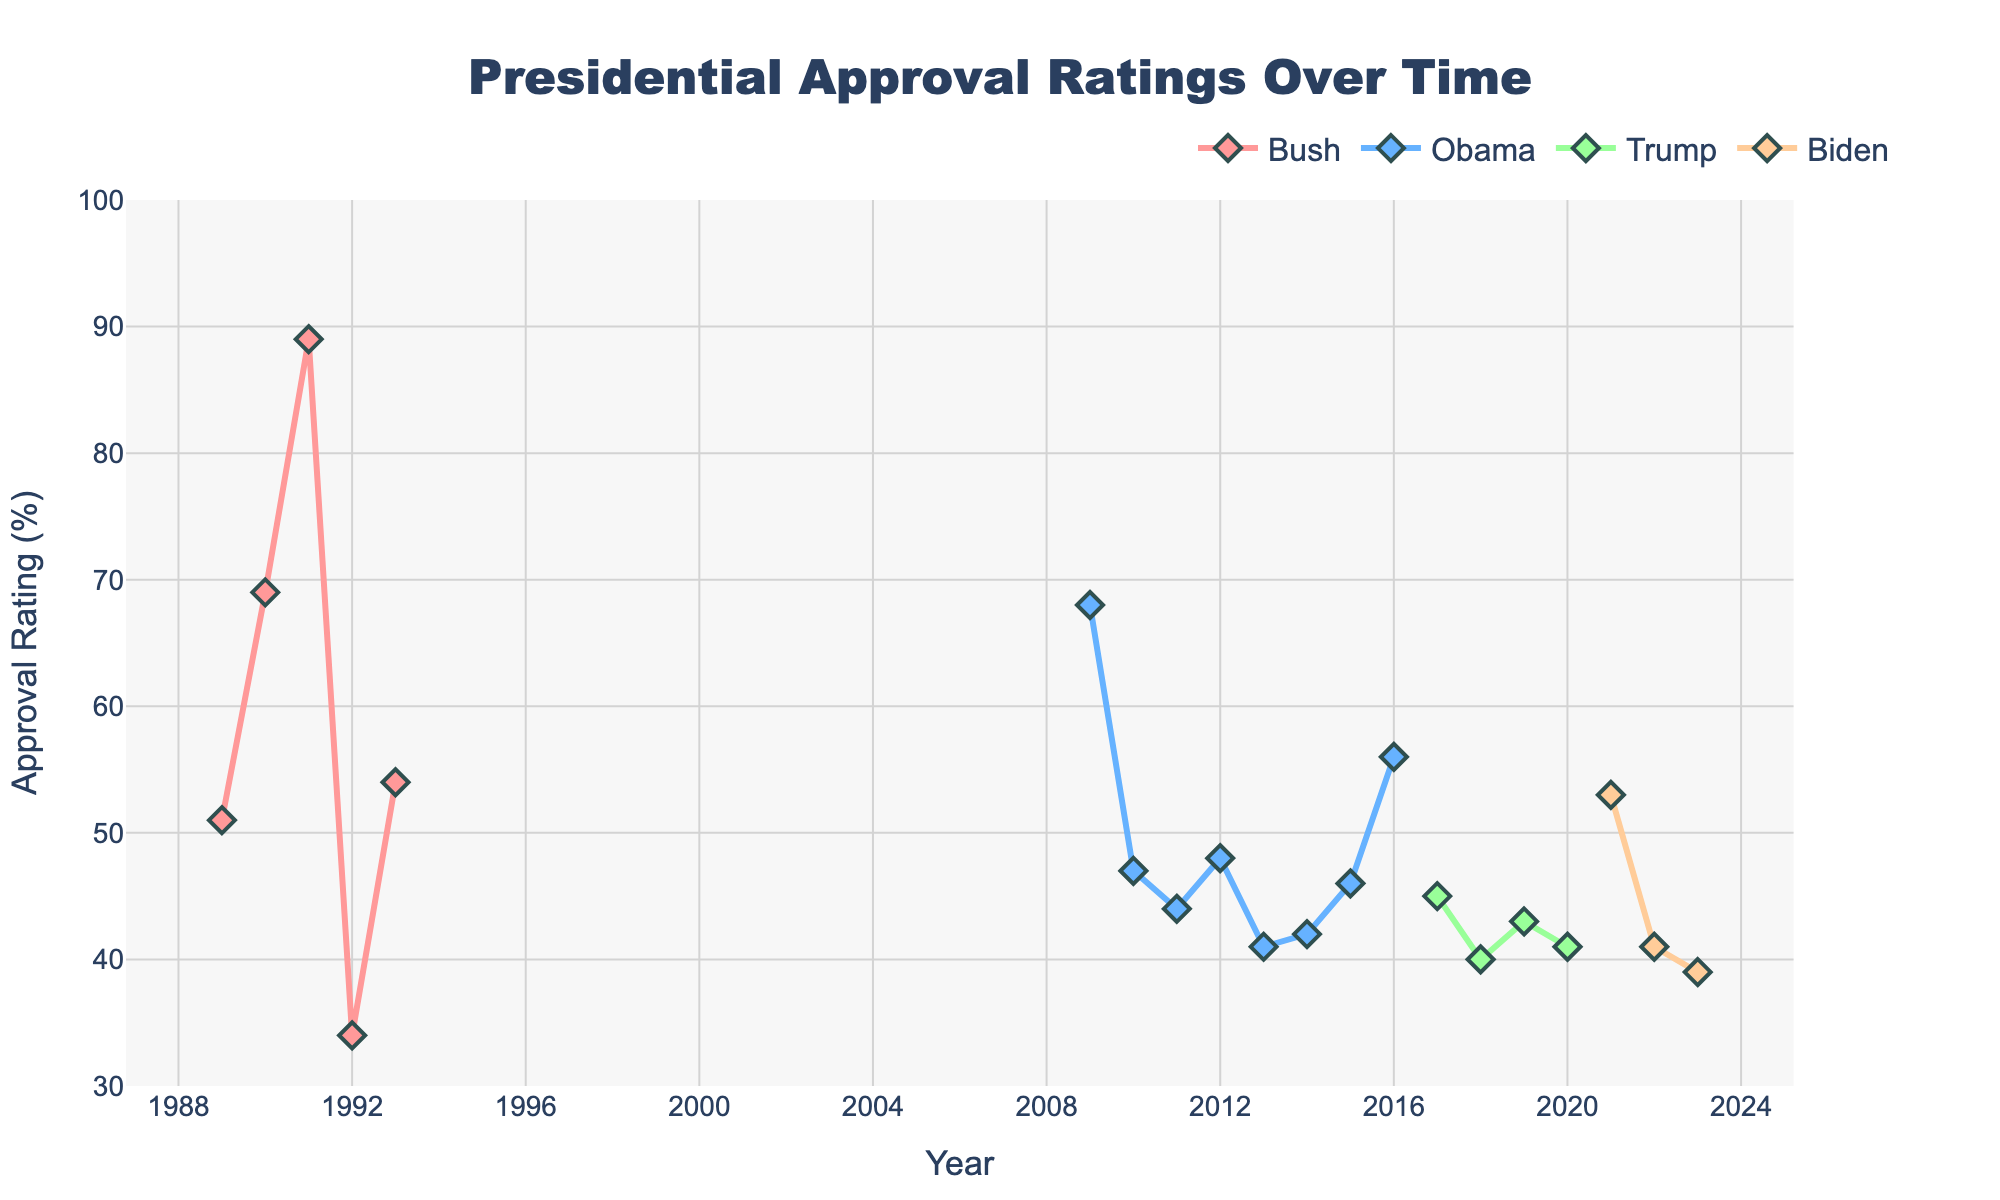Which president had the highest approval rating at any point during their term? First, identify the highest points on each line. Bush's line reaches its peak at 89%. The other presidents' lines do not surpass this value.
Answer: Bush During which year did Biden's approval rating drop below 40%? Observe the trend of Biden's line, and note that it drops below 40% in 2023.
Answer: 2023 What is the approximate average approval rating for Obama throughout his term presented in the data? Calculate the average of the values given for Obama: (68 + 47 + 44 + 48 + 41 + 42 + 46 + 56)/8 ≈ 48. In total: (68 + 47 + 44 + 48 + 41 + 42 + 46 + 56) = 392; 392/8 = 49.
Answer: 49 How many years did Bush’s approval rating remain above 50%? Observe Bush's line and count the years where the approval rate is above 50%. Those years are 1989, 1990, and 1991 (3 years in total).
Answer: 3 Compare the approval rating trends for Trump and Biden. During which period did their approval ratings intersect? Look for the point where Trump’s and Biden’s lines overlap or intersect, which happens around the transition period in 2021.
Answer: 2021 Which president experienced the largest drop in approval rating in a single year? Identify the largest drop within a single year for each president. Bush's drop was from 1991 to 1992 (89% to 34%, a drop of 55%). This is the largest drop when compared with others.
Answer: Bush from 1991 to 1992 What is the difference in approval ratings between the highest point for Obama and the lowest point for Trump? Identify and subtract the lowest point of Trump (40%) from the highest point of Obama (68%). So, 68% - 40% = 28%.
Answer: 28% Which president has the most fluctuating approval ratings? Look at the general variances in the trend lines. Bush’s line appears to have the most severe fluctuations, especially considering the peak in 1991 and the sharp drop in 1992.
Answer: Bush 